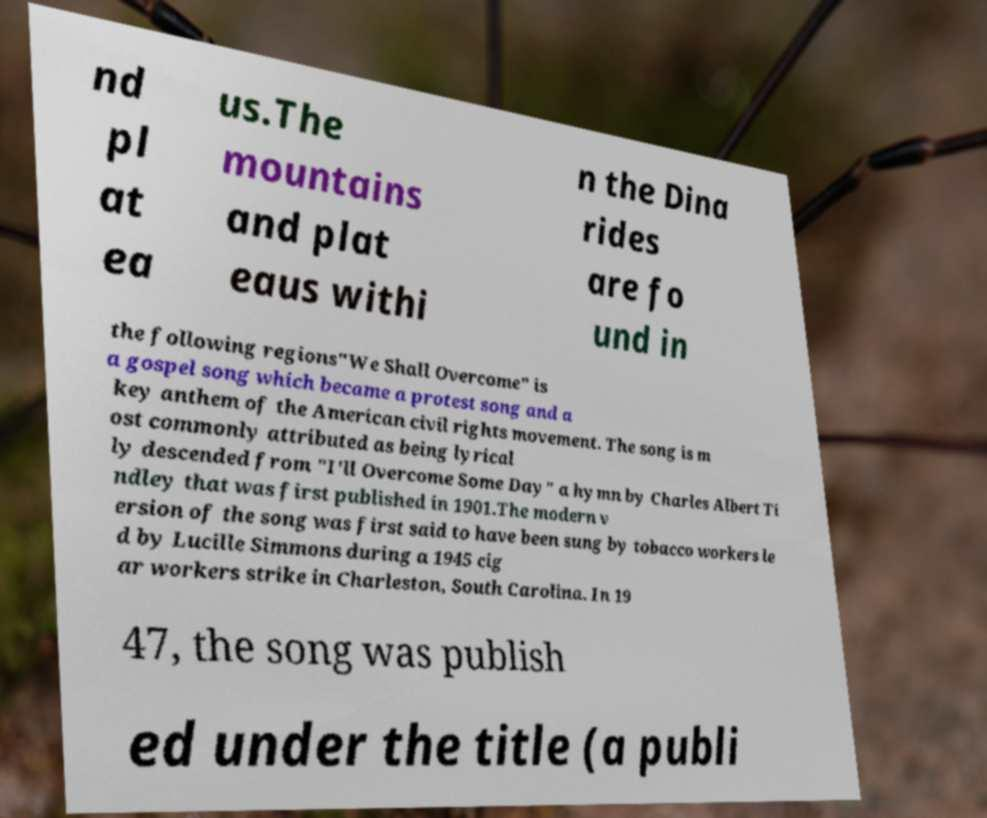Please identify and transcribe the text found in this image. nd pl at ea us.The mountains and plat eaus withi n the Dina rides are fo und in the following regions"We Shall Overcome" is a gospel song which became a protest song and a key anthem of the American civil rights movement. The song is m ost commonly attributed as being lyrical ly descended from "I'll Overcome Some Day" a hymn by Charles Albert Ti ndley that was first published in 1901.The modern v ersion of the song was first said to have been sung by tobacco workers le d by Lucille Simmons during a 1945 cig ar workers strike in Charleston, South Carolina. In 19 47, the song was publish ed under the title (a publi 